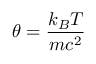<formula> <loc_0><loc_0><loc_500><loc_500>\theta = \frac { k _ { B } T } { m c ^ { 2 } }</formula> 